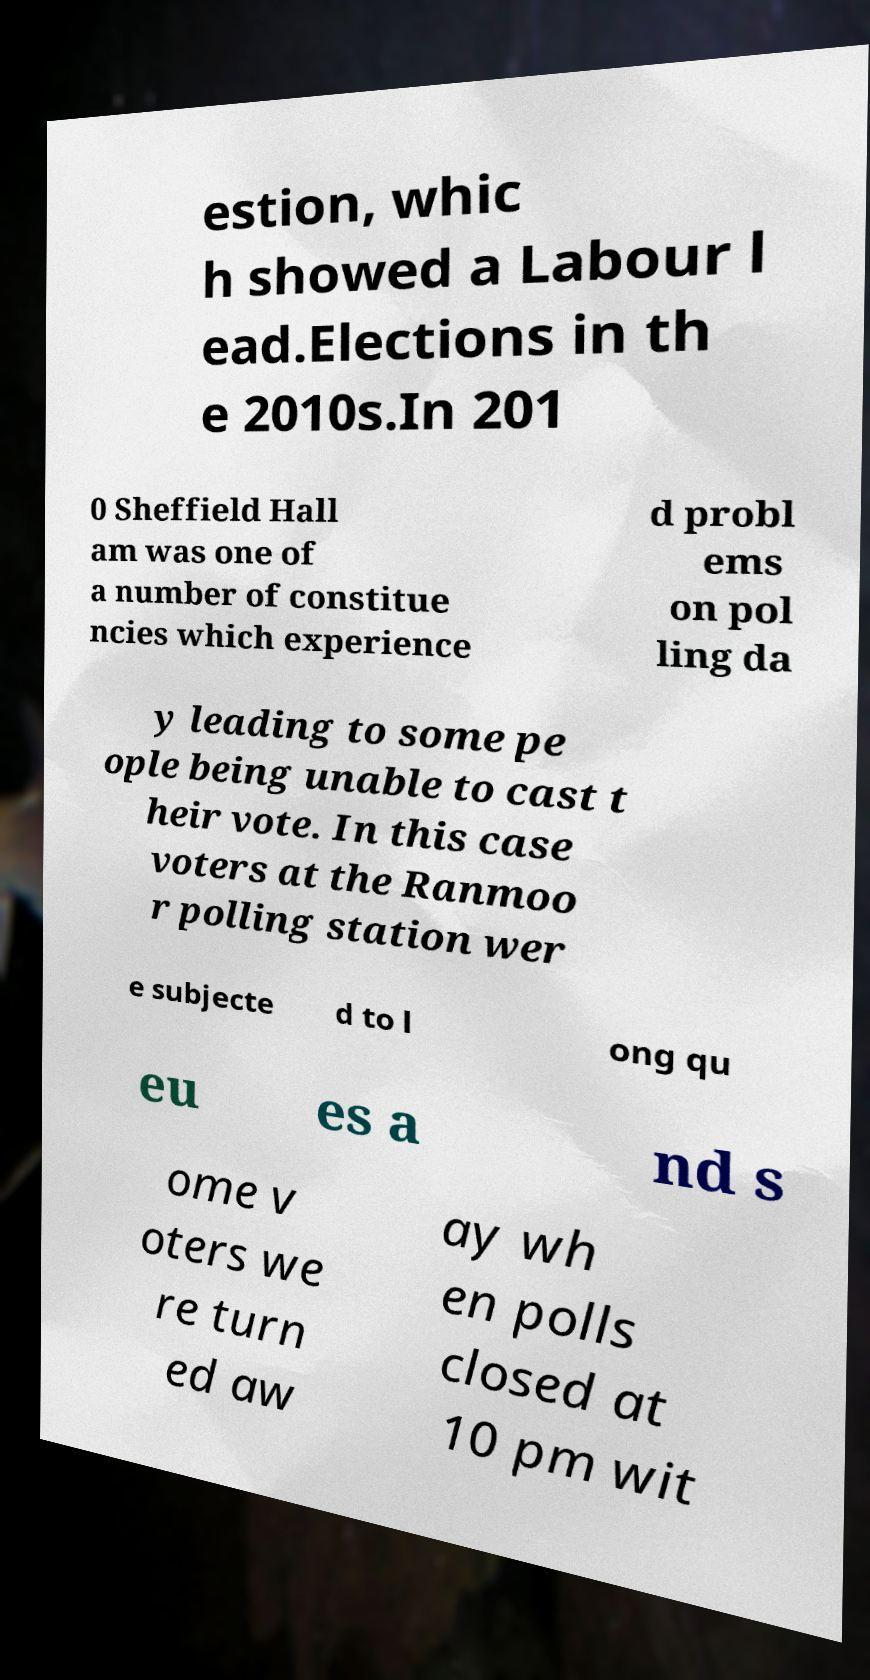Could you extract and type out the text from this image? estion, whic h showed a Labour l ead.Elections in th e 2010s.In 201 0 Sheffield Hall am was one of a number of constitue ncies which experience d probl ems on pol ling da y leading to some pe ople being unable to cast t heir vote. In this case voters at the Ranmoo r polling station wer e subjecte d to l ong qu eu es a nd s ome v oters we re turn ed aw ay wh en polls closed at 10 pm wit 